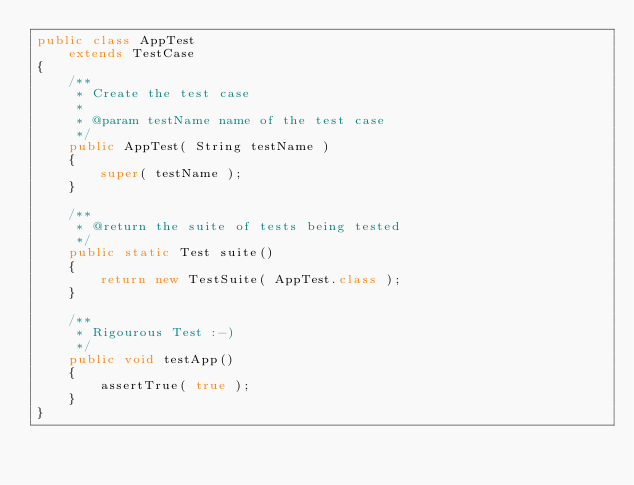Convert code to text. <code><loc_0><loc_0><loc_500><loc_500><_Java_>public class AppTest 
    extends TestCase
{
    /**
     * Create the test case
     *
     * @param testName name of the test case
     */
    public AppTest( String testName )
    {
        super( testName );
    }

    /**
     * @return the suite of tests being tested
     */
    public static Test suite()
    {
        return new TestSuite( AppTest.class );
    }

    /**
     * Rigourous Test :-)
     */
    public void testApp()
    {
        assertTrue( true );
    }
}
</code> 